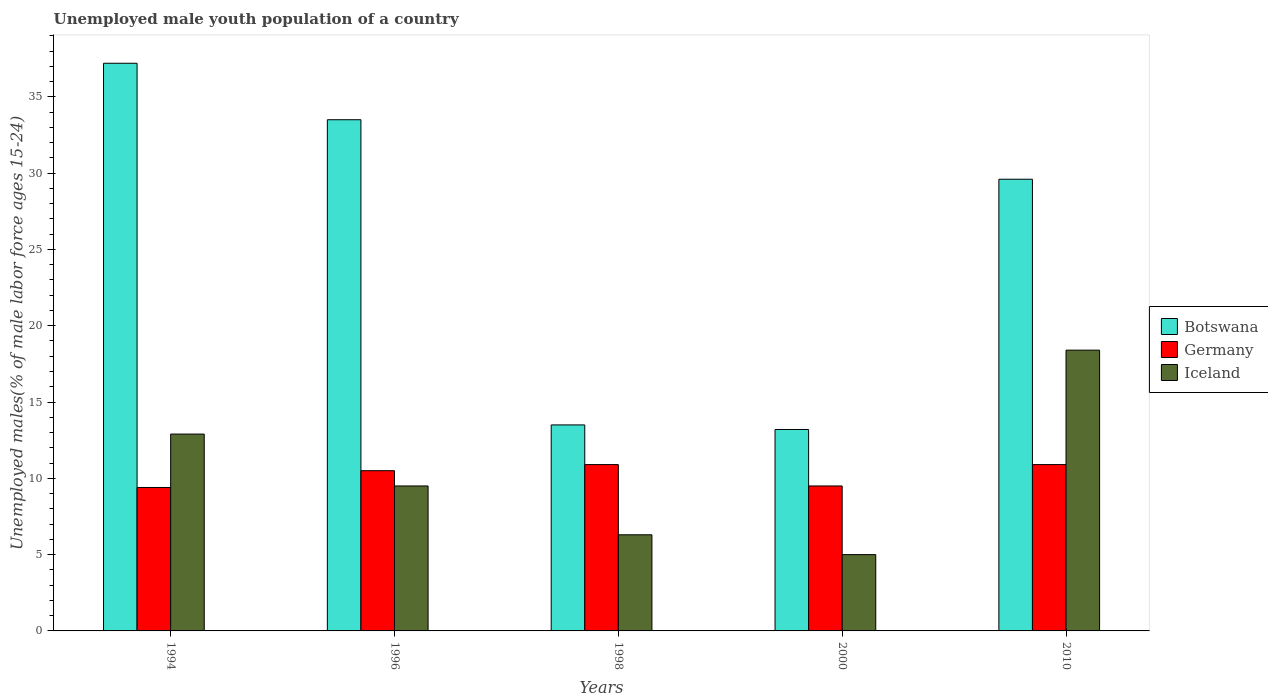How many different coloured bars are there?
Your answer should be compact. 3. How many groups of bars are there?
Your answer should be compact. 5. How many bars are there on the 2nd tick from the right?
Make the answer very short. 3. Across all years, what is the maximum percentage of unemployed male youth population in Germany?
Ensure brevity in your answer.  10.9. Across all years, what is the minimum percentage of unemployed male youth population in Iceland?
Make the answer very short. 5. In which year was the percentage of unemployed male youth population in Iceland minimum?
Provide a short and direct response. 2000. What is the total percentage of unemployed male youth population in Iceland in the graph?
Provide a short and direct response. 52.1. What is the difference between the percentage of unemployed male youth population in Germany in 1994 and that in 1996?
Your answer should be very brief. -1.1. What is the difference between the percentage of unemployed male youth population in Iceland in 2010 and the percentage of unemployed male youth population in Germany in 1998?
Ensure brevity in your answer.  7.5. What is the average percentage of unemployed male youth population in Botswana per year?
Make the answer very short. 25.4. In the year 2010, what is the difference between the percentage of unemployed male youth population in Iceland and percentage of unemployed male youth population in Germany?
Ensure brevity in your answer.  7.5. In how many years, is the percentage of unemployed male youth population in Iceland greater than 2 %?
Your answer should be very brief. 5. What is the ratio of the percentage of unemployed male youth population in Botswana in 1994 to that in 1996?
Provide a succinct answer. 1.11. Is the difference between the percentage of unemployed male youth population in Iceland in 2000 and 2010 greater than the difference between the percentage of unemployed male youth population in Germany in 2000 and 2010?
Your response must be concise. No. What is the difference between the highest and the second highest percentage of unemployed male youth population in Germany?
Your answer should be compact. 0. What is the difference between the highest and the lowest percentage of unemployed male youth population in Iceland?
Your response must be concise. 13.4. Is the sum of the percentage of unemployed male youth population in Iceland in 1994 and 2000 greater than the maximum percentage of unemployed male youth population in Botswana across all years?
Your response must be concise. No. What does the 3rd bar from the left in 1994 represents?
Make the answer very short. Iceland. What does the 1st bar from the right in 2010 represents?
Your answer should be compact. Iceland. Is it the case that in every year, the sum of the percentage of unemployed male youth population in Botswana and percentage of unemployed male youth population in Iceland is greater than the percentage of unemployed male youth population in Germany?
Keep it short and to the point. Yes. Are all the bars in the graph horizontal?
Your answer should be very brief. No. Are the values on the major ticks of Y-axis written in scientific E-notation?
Give a very brief answer. No. What is the title of the graph?
Offer a very short reply. Unemployed male youth population of a country. Does "New Caledonia" appear as one of the legend labels in the graph?
Your answer should be compact. No. What is the label or title of the Y-axis?
Offer a terse response. Unemployed males(% of male labor force ages 15-24). What is the Unemployed males(% of male labor force ages 15-24) of Botswana in 1994?
Your answer should be very brief. 37.2. What is the Unemployed males(% of male labor force ages 15-24) in Germany in 1994?
Ensure brevity in your answer.  9.4. What is the Unemployed males(% of male labor force ages 15-24) in Iceland in 1994?
Give a very brief answer. 12.9. What is the Unemployed males(% of male labor force ages 15-24) of Botswana in 1996?
Keep it short and to the point. 33.5. What is the Unemployed males(% of male labor force ages 15-24) in Botswana in 1998?
Offer a very short reply. 13.5. What is the Unemployed males(% of male labor force ages 15-24) of Germany in 1998?
Ensure brevity in your answer.  10.9. What is the Unemployed males(% of male labor force ages 15-24) in Iceland in 1998?
Provide a succinct answer. 6.3. What is the Unemployed males(% of male labor force ages 15-24) of Botswana in 2000?
Offer a terse response. 13.2. What is the Unemployed males(% of male labor force ages 15-24) in Germany in 2000?
Give a very brief answer. 9.5. What is the Unemployed males(% of male labor force ages 15-24) in Iceland in 2000?
Keep it short and to the point. 5. What is the Unemployed males(% of male labor force ages 15-24) in Botswana in 2010?
Keep it short and to the point. 29.6. What is the Unemployed males(% of male labor force ages 15-24) of Germany in 2010?
Your response must be concise. 10.9. What is the Unemployed males(% of male labor force ages 15-24) in Iceland in 2010?
Offer a terse response. 18.4. Across all years, what is the maximum Unemployed males(% of male labor force ages 15-24) of Botswana?
Offer a terse response. 37.2. Across all years, what is the maximum Unemployed males(% of male labor force ages 15-24) in Germany?
Ensure brevity in your answer.  10.9. Across all years, what is the maximum Unemployed males(% of male labor force ages 15-24) of Iceland?
Offer a terse response. 18.4. Across all years, what is the minimum Unemployed males(% of male labor force ages 15-24) in Botswana?
Give a very brief answer. 13.2. Across all years, what is the minimum Unemployed males(% of male labor force ages 15-24) of Germany?
Provide a short and direct response. 9.4. What is the total Unemployed males(% of male labor force ages 15-24) of Botswana in the graph?
Offer a very short reply. 127. What is the total Unemployed males(% of male labor force ages 15-24) of Germany in the graph?
Provide a short and direct response. 51.2. What is the total Unemployed males(% of male labor force ages 15-24) in Iceland in the graph?
Your response must be concise. 52.1. What is the difference between the Unemployed males(% of male labor force ages 15-24) in Botswana in 1994 and that in 1998?
Provide a short and direct response. 23.7. What is the difference between the Unemployed males(% of male labor force ages 15-24) in Germany in 1994 and that in 1998?
Provide a succinct answer. -1.5. What is the difference between the Unemployed males(% of male labor force ages 15-24) in Iceland in 1994 and that in 1998?
Offer a terse response. 6.6. What is the difference between the Unemployed males(% of male labor force ages 15-24) of Botswana in 1994 and that in 2000?
Give a very brief answer. 24. What is the difference between the Unemployed males(% of male labor force ages 15-24) in Germany in 1994 and that in 2000?
Offer a terse response. -0.1. What is the difference between the Unemployed males(% of male labor force ages 15-24) of Iceland in 1994 and that in 2010?
Offer a terse response. -5.5. What is the difference between the Unemployed males(% of male labor force ages 15-24) of Botswana in 1996 and that in 1998?
Your response must be concise. 20. What is the difference between the Unemployed males(% of male labor force ages 15-24) of Germany in 1996 and that in 1998?
Provide a short and direct response. -0.4. What is the difference between the Unemployed males(% of male labor force ages 15-24) in Iceland in 1996 and that in 1998?
Provide a succinct answer. 3.2. What is the difference between the Unemployed males(% of male labor force ages 15-24) of Botswana in 1996 and that in 2000?
Provide a short and direct response. 20.3. What is the difference between the Unemployed males(% of male labor force ages 15-24) in Germany in 1996 and that in 2000?
Provide a succinct answer. 1. What is the difference between the Unemployed males(% of male labor force ages 15-24) of Iceland in 1996 and that in 2000?
Offer a very short reply. 4.5. What is the difference between the Unemployed males(% of male labor force ages 15-24) in Iceland in 1998 and that in 2000?
Your answer should be very brief. 1.3. What is the difference between the Unemployed males(% of male labor force ages 15-24) in Botswana in 1998 and that in 2010?
Give a very brief answer. -16.1. What is the difference between the Unemployed males(% of male labor force ages 15-24) in Botswana in 2000 and that in 2010?
Keep it short and to the point. -16.4. What is the difference between the Unemployed males(% of male labor force ages 15-24) of Botswana in 1994 and the Unemployed males(% of male labor force ages 15-24) of Germany in 1996?
Your answer should be compact. 26.7. What is the difference between the Unemployed males(% of male labor force ages 15-24) of Botswana in 1994 and the Unemployed males(% of male labor force ages 15-24) of Iceland in 1996?
Your answer should be very brief. 27.7. What is the difference between the Unemployed males(% of male labor force ages 15-24) in Germany in 1994 and the Unemployed males(% of male labor force ages 15-24) in Iceland in 1996?
Your answer should be compact. -0.1. What is the difference between the Unemployed males(% of male labor force ages 15-24) of Botswana in 1994 and the Unemployed males(% of male labor force ages 15-24) of Germany in 1998?
Your answer should be very brief. 26.3. What is the difference between the Unemployed males(% of male labor force ages 15-24) of Botswana in 1994 and the Unemployed males(% of male labor force ages 15-24) of Iceland in 1998?
Ensure brevity in your answer.  30.9. What is the difference between the Unemployed males(% of male labor force ages 15-24) in Germany in 1994 and the Unemployed males(% of male labor force ages 15-24) in Iceland in 1998?
Offer a very short reply. 3.1. What is the difference between the Unemployed males(% of male labor force ages 15-24) of Botswana in 1994 and the Unemployed males(% of male labor force ages 15-24) of Germany in 2000?
Make the answer very short. 27.7. What is the difference between the Unemployed males(% of male labor force ages 15-24) in Botswana in 1994 and the Unemployed males(% of male labor force ages 15-24) in Iceland in 2000?
Make the answer very short. 32.2. What is the difference between the Unemployed males(% of male labor force ages 15-24) of Germany in 1994 and the Unemployed males(% of male labor force ages 15-24) of Iceland in 2000?
Keep it short and to the point. 4.4. What is the difference between the Unemployed males(% of male labor force ages 15-24) in Botswana in 1994 and the Unemployed males(% of male labor force ages 15-24) in Germany in 2010?
Provide a short and direct response. 26.3. What is the difference between the Unemployed males(% of male labor force ages 15-24) of Germany in 1994 and the Unemployed males(% of male labor force ages 15-24) of Iceland in 2010?
Offer a terse response. -9. What is the difference between the Unemployed males(% of male labor force ages 15-24) in Botswana in 1996 and the Unemployed males(% of male labor force ages 15-24) in Germany in 1998?
Your answer should be very brief. 22.6. What is the difference between the Unemployed males(% of male labor force ages 15-24) in Botswana in 1996 and the Unemployed males(% of male labor force ages 15-24) in Iceland in 1998?
Make the answer very short. 27.2. What is the difference between the Unemployed males(% of male labor force ages 15-24) in Germany in 1996 and the Unemployed males(% of male labor force ages 15-24) in Iceland in 1998?
Provide a succinct answer. 4.2. What is the difference between the Unemployed males(% of male labor force ages 15-24) in Botswana in 1996 and the Unemployed males(% of male labor force ages 15-24) in Germany in 2000?
Make the answer very short. 24. What is the difference between the Unemployed males(% of male labor force ages 15-24) of Botswana in 1996 and the Unemployed males(% of male labor force ages 15-24) of Iceland in 2000?
Your response must be concise. 28.5. What is the difference between the Unemployed males(% of male labor force ages 15-24) of Botswana in 1996 and the Unemployed males(% of male labor force ages 15-24) of Germany in 2010?
Give a very brief answer. 22.6. What is the difference between the Unemployed males(% of male labor force ages 15-24) in Botswana in 1998 and the Unemployed males(% of male labor force ages 15-24) in Iceland in 2010?
Offer a very short reply. -4.9. What is the difference between the Unemployed males(% of male labor force ages 15-24) of Germany in 1998 and the Unemployed males(% of male labor force ages 15-24) of Iceland in 2010?
Your answer should be compact. -7.5. What is the difference between the Unemployed males(% of male labor force ages 15-24) in Germany in 2000 and the Unemployed males(% of male labor force ages 15-24) in Iceland in 2010?
Your answer should be compact. -8.9. What is the average Unemployed males(% of male labor force ages 15-24) of Botswana per year?
Your response must be concise. 25.4. What is the average Unemployed males(% of male labor force ages 15-24) in Germany per year?
Provide a succinct answer. 10.24. What is the average Unemployed males(% of male labor force ages 15-24) in Iceland per year?
Your answer should be compact. 10.42. In the year 1994, what is the difference between the Unemployed males(% of male labor force ages 15-24) of Botswana and Unemployed males(% of male labor force ages 15-24) of Germany?
Your answer should be very brief. 27.8. In the year 1994, what is the difference between the Unemployed males(% of male labor force ages 15-24) in Botswana and Unemployed males(% of male labor force ages 15-24) in Iceland?
Your answer should be very brief. 24.3. In the year 1994, what is the difference between the Unemployed males(% of male labor force ages 15-24) of Germany and Unemployed males(% of male labor force ages 15-24) of Iceland?
Provide a succinct answer. -3.5. In the year 1996, what is the difference between the Unemployed males(% of male labor force ages 15-24) of Botswana and Unemployed males(% of male labor force ages 15-24) of Germany?
Provide a succinct answer. 23. In the year 1996, what is the difference between the Unemployed males(% of male labor force ages 15-24) of Botswana and Unemployed males(% of male labor force ages 15-24) of Iceland?
Provide a short and direct response. 24. In the year 1998, what is the difference between the Unemployed males(% of male labor force ages 15-24) of Botswana and Unemployed males(% of male labor force ages 15-24) of Germany?
Provide a succinct answer. 2.6. In the year 1998, what is the difference between the Unemployed males(% of male labor force ages 15-24) in Botswana and Unemployed males(% of male labor force ages 15-24) in Iceland?
Provide a short and direct response. 7.2. In the year 2000, what is the difference between the Unemployed males(% of male labor force ages 15-24) of Botswana and Unemployed males(% of male labor force ages 15-24) of Germany?
Provide a short and direct response. 3.7. In the year 2000, what is the difference between the Unemployed males(% of male labor force ages 15-24) in Germany and Unemployed males(% of male labor force ages 15-24) in Iceland?
Your answer should be compact. 4.5. What is the ratio of the Unemployed males(% of male labor force ages 15-24) of Botswana in 1994 to that in 1996?
Your answer should be compact. 1.11. What is the ratio of the Unemployed males(% of male labor force ages 15-24) of Germany in 1994 to that in 1996?
Provide a short and direct response. 0.9. What is the ratio of the Unemployed males(% of male labor force ages 15-24) in Iceland in 1994 to that in 1996?
Give a very brief answer. 1.36. What is the ratio of the Unemployed males(% of male labor force ages 15-24) in Botswana in 1994 to that in 1998?
Offer a terse response. 2.76. What is the ratio of the Unemployed males(% of male labor force ages 15-24) in Germany in 1994 to that in 1998?
Offer a terse response. 0.86. What is the ratio of the Unemployed males(% of male labor force ages 15-24) of Iceland in 1994 to that in 1998?
Your answer should be compact. 2.05. What is the ratio of the Unemployed males(% of male labor force ages 15-24) of Botswana in 1994 to that in 2000?
Offer a terse response. 2.82. What is the ratio of the Unemployed males(% of male labor force ages 15-24) of Iceland in 1994 to that in 2000?
Your answer should be very brief. 2.58. What is the ratio of the Unemployed males(% of male labor force ages 15-24) of Botswana in 1994 to that in 2010?
Keep it short and to the point. 1.26. What is the ratio of the Unemployed males(% of male labor force ages 15-24) in Germany in 1994 to that in 2010?
Offer a very short reply. 0.86. What is the ratio of the Unemployed males(% of male labor force ages 15-24) in Iceland in 1994 to that in 2010?
Keep it short and to the point. 0.7. What is the ratio of the Unemployed males(% of male labor force ages 15-24) in Botswana in 1996 to that in 1998?
Offer a terse response. 2.48. What is the ratio of the Unemployed males(% of male labor force ages 15-24) in Germany in 1996 to that in 1998?
Your response must be concise. 0.96. What is the ratio of the Unemployed males(% of male labor force ages 15-24) of Iceland in 1996 to that in 1998?
Provide a succinct answer. 1.51. What is the ratio of the Unemployed males(% of male labor force ages 15-24) in Botswana in 1996 to that in 2000?
Provide a succinct answer. 2.54. What is the ratio of the Unemployed males(% of male labor force ages 15-24) of Germany in 1996 to that in 2000?
Give a very brief answer. 1.11. What is the ratio of the Unemployed males(% of male labor force ages 15-24) of Iceland in 1996 to that in 2000?
Provide a short and direct response. 1.9. What is the ratio of the Unemployed males(% of male labor force ages 15-24) in Botswana in 1996 to that in 2010?
Your answer should be compact. 1.13. What is the ratio of the Unemployed males(% of male labor force ages 15-24) in Germany in 1996 to that in 2010?
Offer a very short reply. 0.96. What is the ratio of the Unemployed males(% of male labor force ages 15-24) in Iceland in 1996 to that in 2010?
Make the answer very short. 0.52. What is the ratio of the Unemployed males(% of male labor force ages 15-24) of Botswana in 1998 to that in 2000?
Your answer should be compact. 1.02. What is the ratio of the Unemployed males(% of male labor force ages 15-24) in Germany in 1998 to that in 2000?
Offer a very short reply. 1.15. What is the ratio of the Unemployed males(% of male labor force ages 15-24) of Iceland in 1998 to that in 2000?
Give a very brief answer. 1.26. What is the ratio of the Unemployed males(% of male labor force ages 15-24) of Botswana in 1998 to that in 2010?
Your response must be concise. 0.46. What is the ratio of the Unemployed males(% of male labor force ages 15-24) in Germany in 1998 to that in 2010?
Provide a short and direct response. 1. What is the ratio of the Unemployed males(% of male labor force ages 15-24) in Iceland in 1998 to that in 2010?
Offer a very short reply. 0.34. What is the ratio of the Unemployed males(% of male labor force ages 15-24) of Botswana in 2000 to that in 2010?
Make the answer very short. 0.45. What is the ratio of the Unemployed males(% of male labor force ages 15-24) in Germany in 2000 to that in 2010?
Your answer should be compact. 0.87. What is the ratio of the Unemployed males(% of male labor force ages 15-24) of Iceland in 2000 to that in 2010?
Make the answer very short. 0.27. What is the difference between the highest and the second highest Unemployed males(% of male labor force ages 15-24) of Botswana?
Ensure brevity in your answer.  3.7. What is the difference between the highest and the lowest Unemployed males(% of male labor force ages 15-24) of Botswana?
Provide a short and direct response. 24. 